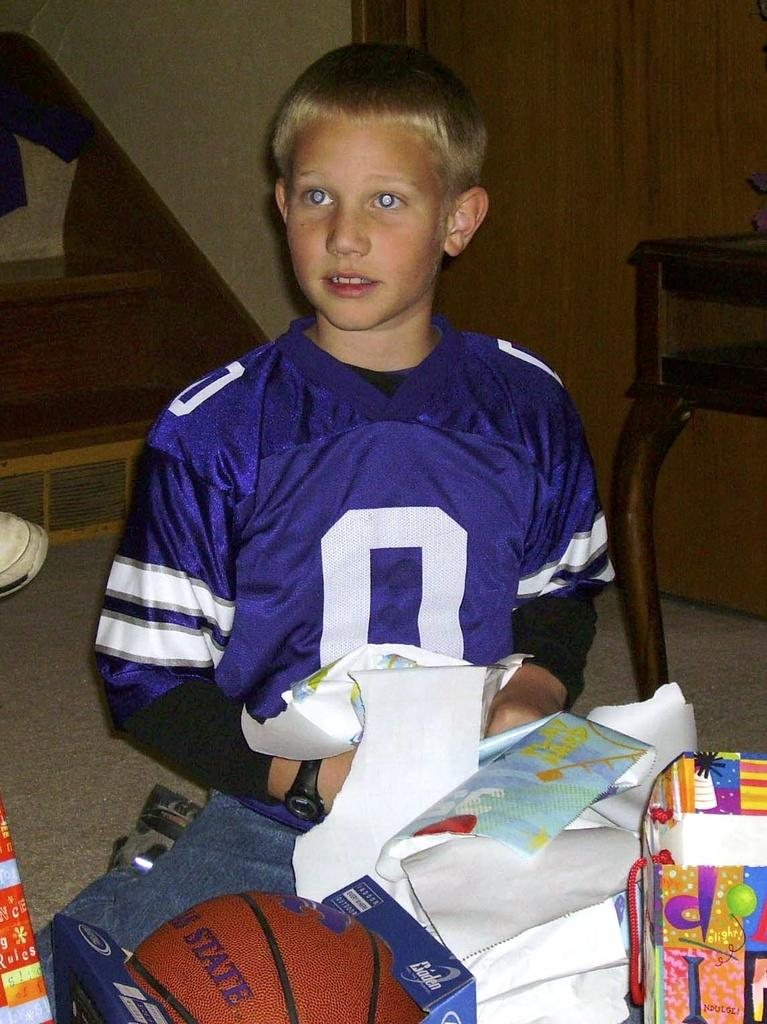<image>
Describe the image concisely. A boy in a number zero jersey opens gifts, including a basketball. 